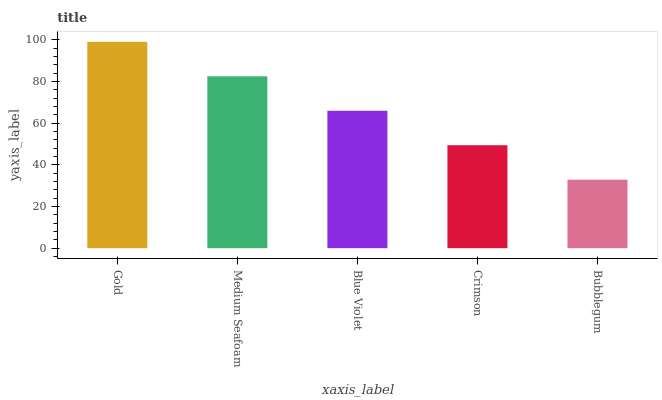Is Bubblegum the minimum?
Answer yes or no. Yes. Is Gold the maximum?
Answer yes or no. Yes. Is Medium Seafoam the minimum?
Answer yes or no. No. Is Medium Seafoam the maximum?
Answer yes or no. No. Is Gold greater than Medium Seafoam?
Answer yes or no. Yes. Is Medium Seafoam less than Gold?
Answer yes or no. Yes. Is Medium Seafoam greater than Gold?
Answer yes or no. No. Is Gold less than Medium Seafoam?
Answer yes or no. No. Is Blue Violet the high median?
Answer yes or no. Yes. Is Blue Violet the low median?
Answer yes or no. Yes. Is Crimson the high median?
Answer yes or no. No. Is Crimson the low median?
Answer yes or no. No. 